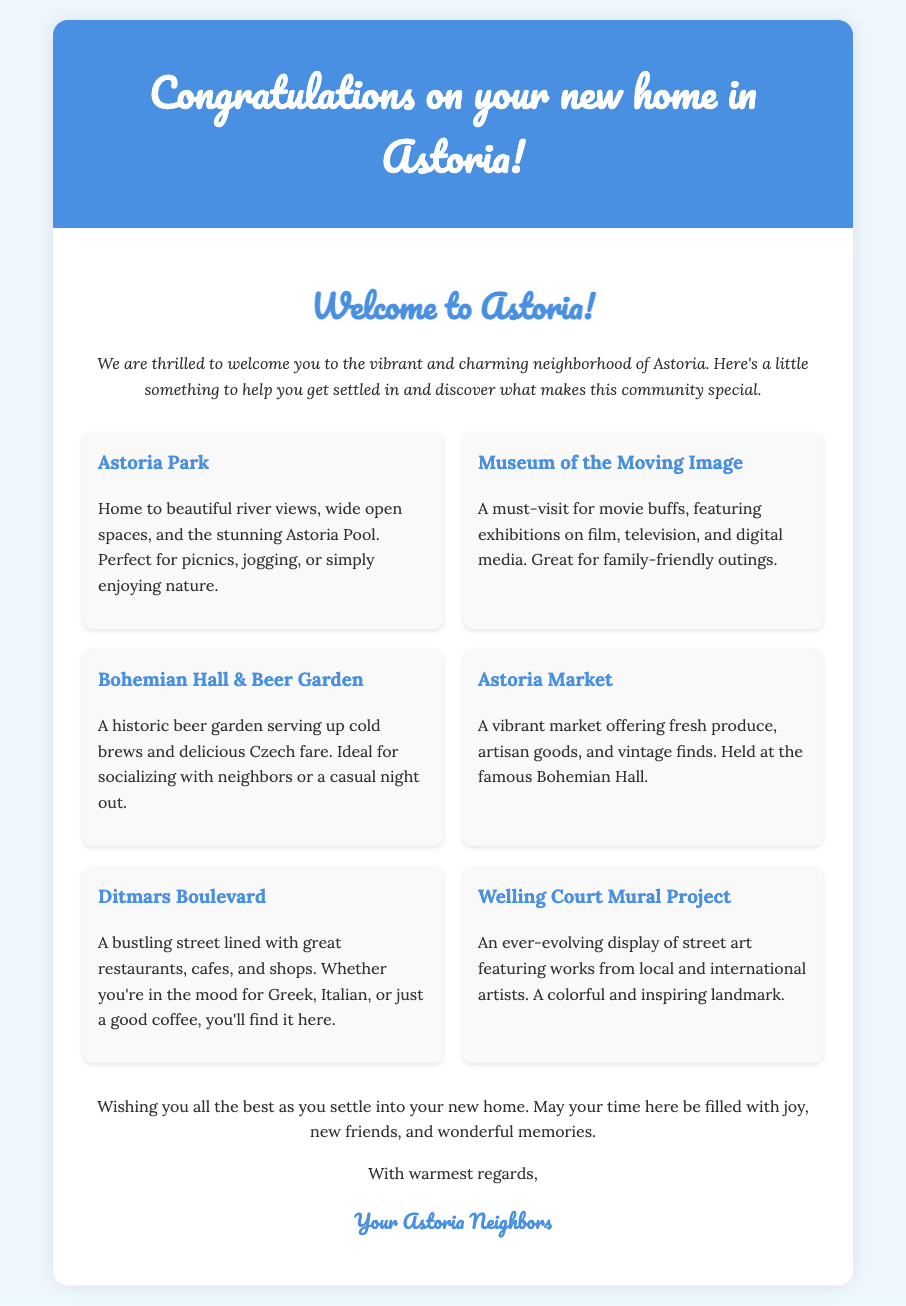What is the name of the card? The title of the card is "Congratulations on your new home in Astoria!"
Answer: Congratulations on your new home in Astoria! What is the introduction about? The introduction expresses excitement about welcoming the new homeowners to the neighborhood of Astoria and encourages them to explore the community.
Answer: Welcoming new homeowners How many highlights are listed in the map? There are a total of six highlights mentioned for the Astoria neighborhood in the document.
Answer: Six What feature is unique to Astoria Park? The document states that Astoria Park features beautiful river views and the stunning Astoria Pool.
Answer: Astoria Pool Which location is described as great for family outings? The Museum of the Moving Image is specifically mentioned as a great place for family-friendly outings.
Answer: Museum of the Moving Image What type of food is served at Bohemian Hall & Beer Garden? The document notes that Bohemian Hall & Beer Garden serves Czech fare.
Answer: Czech fare What do the senders wish for the new homeowners? The senders wish for joy, new friends, and wonderful memories as the new homeowners settle in.
Answer: Joy and wonderful memories What is the closing signature on the card? The closing signature indicates that the card is from "Your Astoria Neighbors."
Answer: Your Astoria Neighbors 